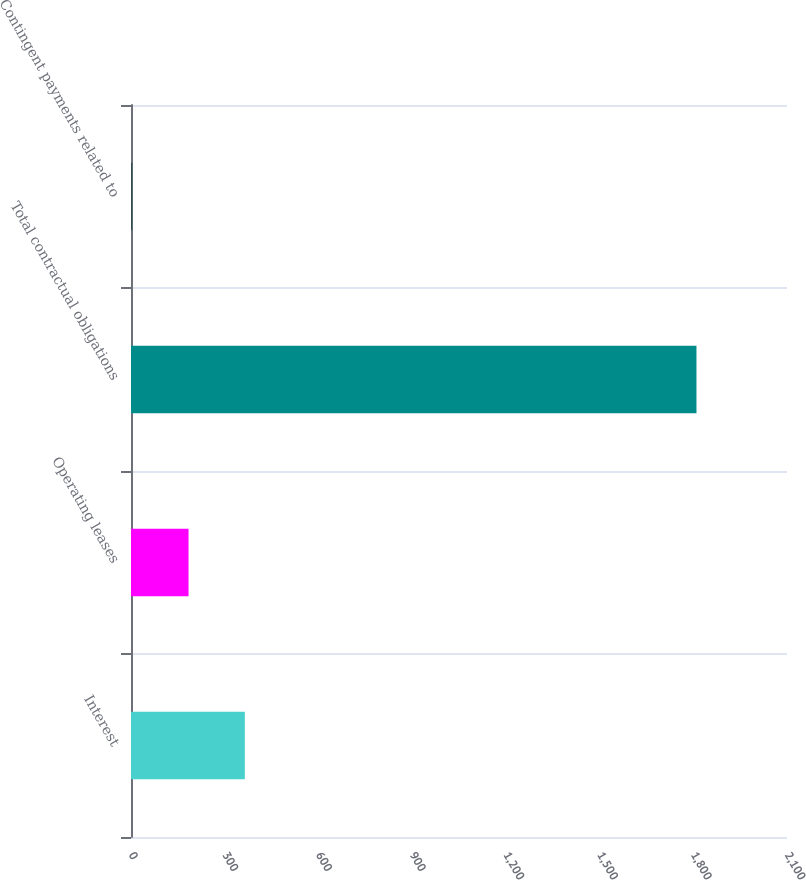Convert chart. <chart><loc_0><loc_0><loc_500><loc_500><bar_chart><fcel>Interest<fcel>Operating leases<fcel>Total contractual obligations<fcel>Contingent payments related to<nl><fcel>364.4<fcel>184.2<fcel>1810.2<fcel>4<nl></chart> 